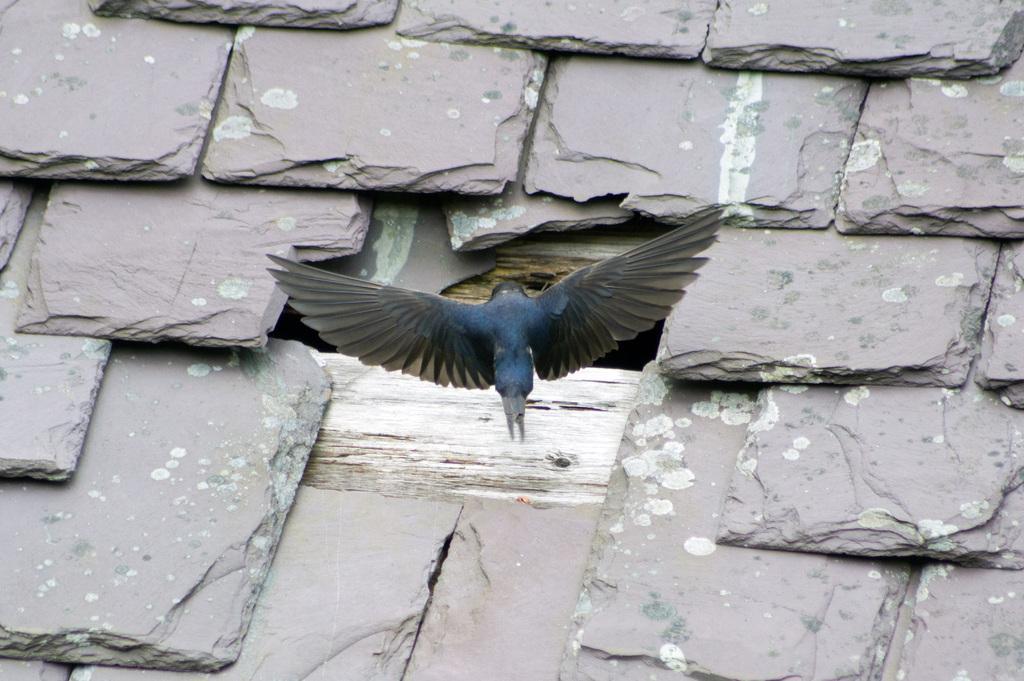Describe this image in one or two sentences. In the center of the image there is a bird. In the background we can see stones. 